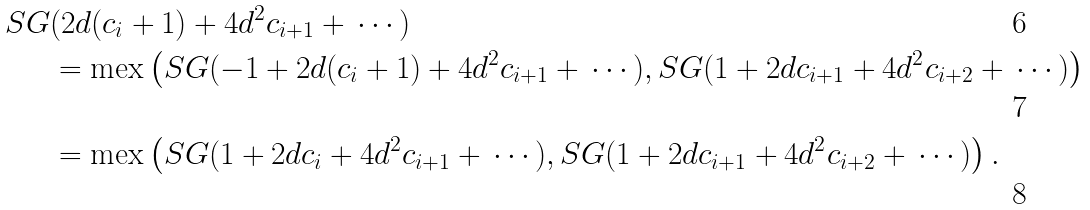<formula> <loc_0><loc_0><loc_500><loc_500>S G & ( 2 d ( c _ { i } + 1 ) + 4 d ^ { 2 } c _ { i + 1 } + \, \cdots ) \\ & = \text {mex} \left ( S G ( - 1 + 2 d ( c _ { i } + 1 ) + 4 d ^ { 2 } c _ { i + 1 } + \, \cdots ) , S G ( 1 + 2 d c _ { i + 1 } + 4 d ^ { 2 } c _ { i + 2 } + \, \cdots ) \right ) \\ & = \text {mex} \left ( S G ( 1 + 2 d c _ { i } + 4 d ^ { 2 } c _ { i + 1 } + \, \cdots ) , S G ( 1 + 2 d c _ { i + 1 } + 4 d ^ { 2 } c _ { i + 2 } + \, \cdots ) \right ) .</formula> 